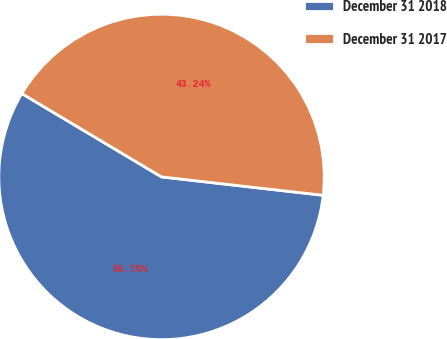Convert chart. <chart><loc_0><loc_0><loc_500><loc_500><pie_chart><fcel>December 31 2018<fcel>December 31 2017<nl><fcel>56.76%<fcel>43.24%<nl></chart> 